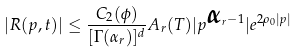Convert formula to latex. <formula><loc_0><loc_0><loc_500><loc_500>| { R } ( p , t ) | \leq \frac { C _ { 2 } ( \phi ) } { [ \Gamma ( \alpha _ { r } ) ] ^ { d } } A _ { r } ( T ) | { p } ^ { { \boldsymbol \alpha } _ { r } - { 1 } } | e ^ { { 2 } \rho _ { 0 } | { p } | }</formula> 